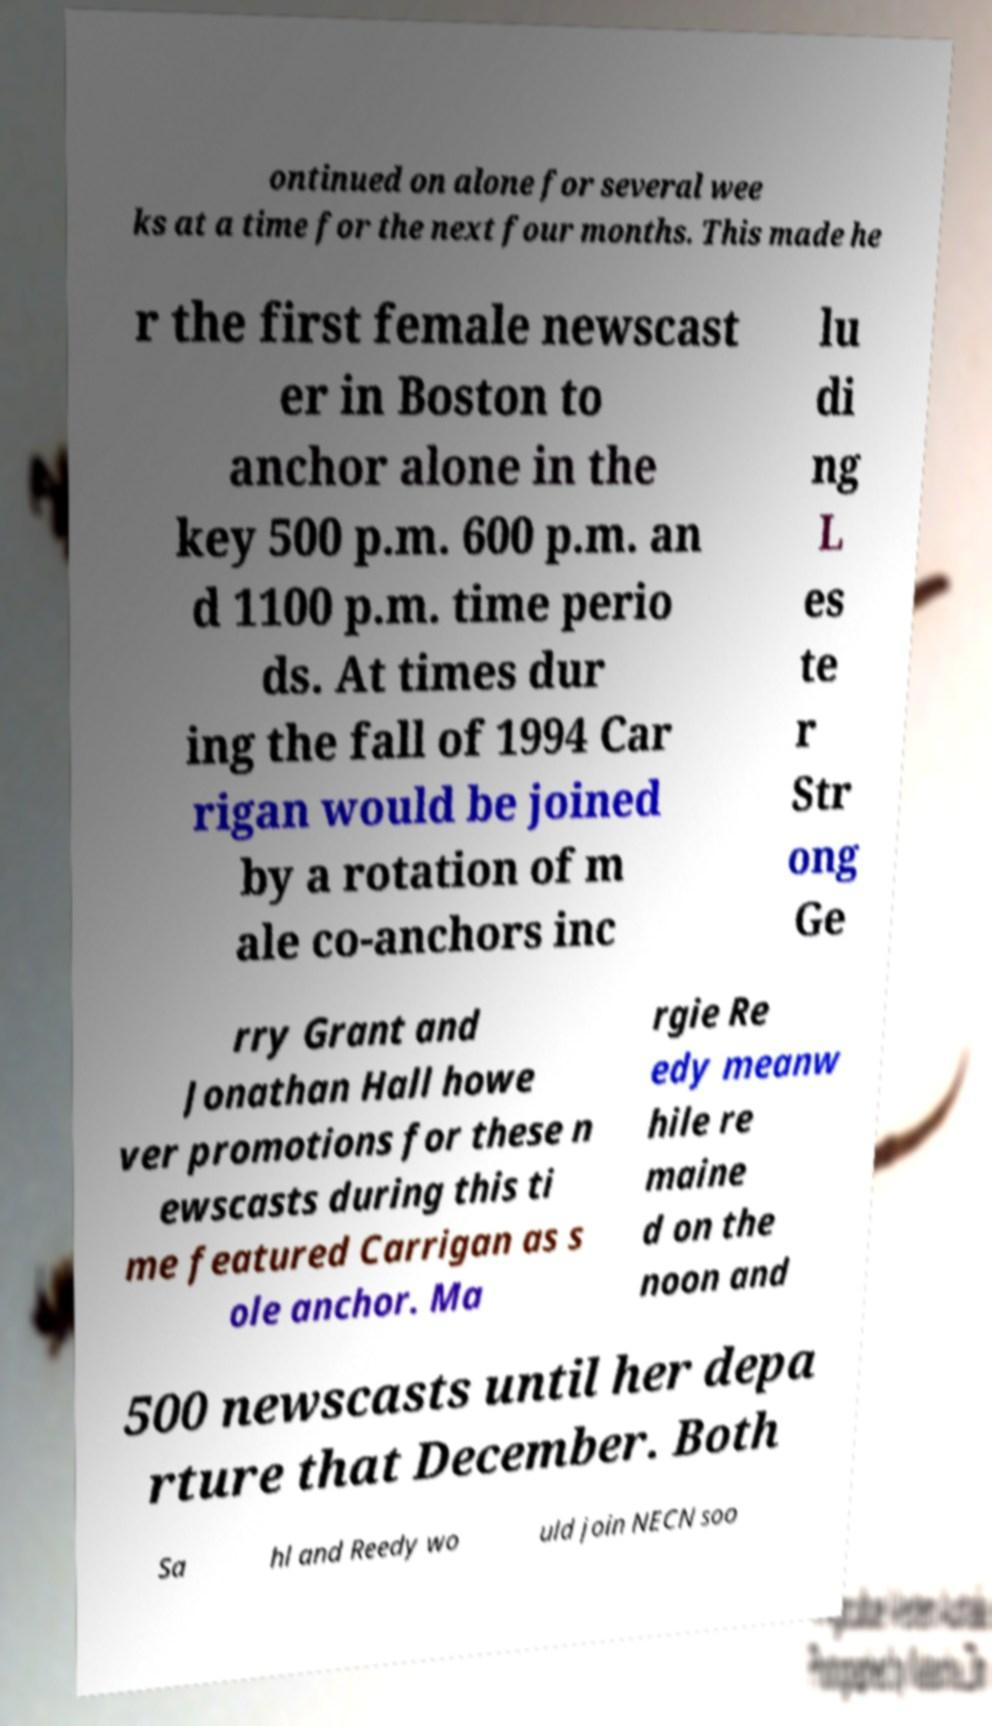Please read and relay the text visible in this image. What does it say? ontinued on alone for several wee ks at a time for the next four months. This made he r the first female newscast er in Boston to anchor alone in the key 500 p.m. 600 p.m. an d 1100 p.m. time perio ds. At times dur ing the fall of 1994 Car rigan would be joined by a rotation of m ale co-anchors inc lu di ng L es te r Str ong Ge rry Grant and Jonathan Hall howe ver promotions for these n ewscasts during this ti me featured Carrigan as s ole anchor. Ma rgie Re edy meanw hile re maine d on the noon and 500 newscasts until her depa rture that December. Both Sa hl and Reedy wo uld join NECN soo 